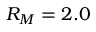<formula> <loc_0><loc_0><loc_500><loc_500>R _ { M } = 2 . 0</formula> 